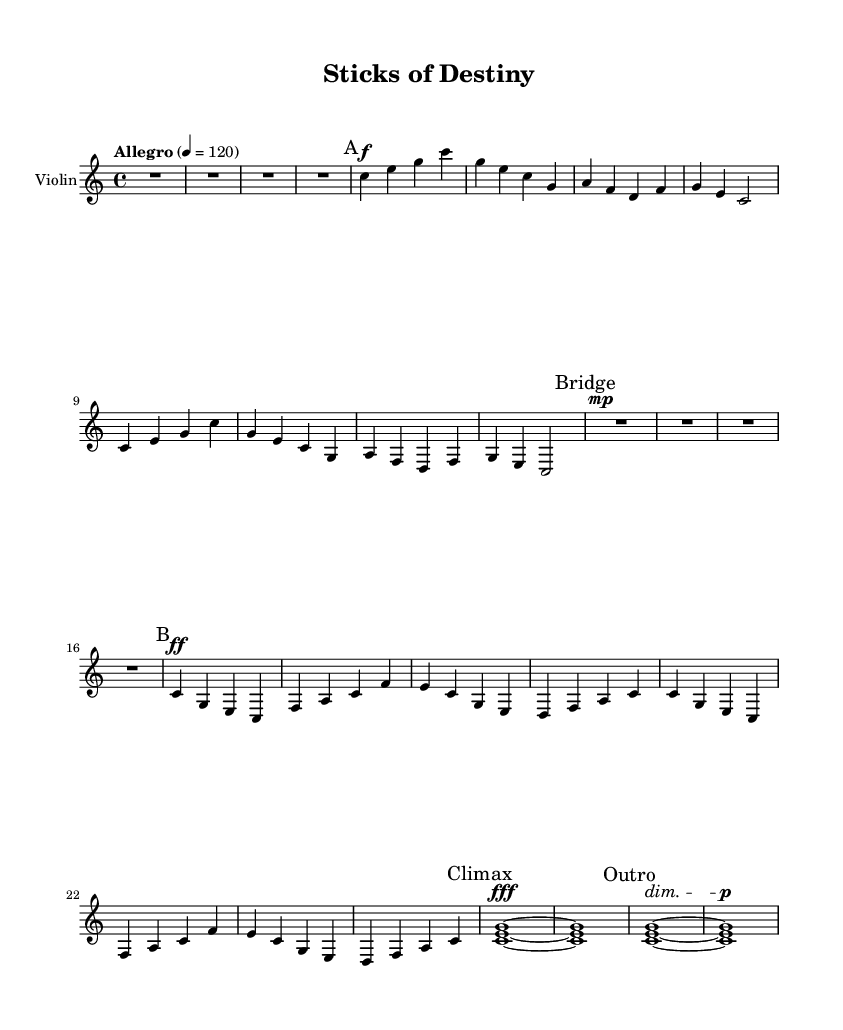What is the key signature of this music? The key signature indicates that the music is in C major, which has no sharps or flats. This can be determined by looking at the key indication at the beginning of the sheet music.
Answer: C major What is the time signature of this piece? The time signature is shown as 4/4 at the beginning of the sheet music, indicating that there are four beats per measure and a quarter note gets one beat.
Answer: 4/4 What is the tempo marking for this piece? The tempo marking is indicated as "Allegro," with a metronome marking of 120 beats per minute, both of which specify the speed of the music.
Answer: Allegro 4 = 120 How many main themes are present in this music? Observing the sections labeled as "A" and "B" in the sheet music, there are two distinct main themes identified within the composition, showcasing contrasting musical ideas.
Answer: 2 What dynamic marking is used at the climax section? In the climax section, the dynamic marking is "fff," indicating that this part of the music should be played very loudly, signifying a peak in the musical intensity.
Answer: fff What is the mood suggested by the outro of this piece? The outro features a diminuendo, indicated by the dynamic marking "dim," which suggests that the music should gradually get quieter, creating a reflective or conclusive mood.
Answer: Diminuendo 